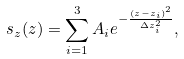Convert formula to latex. <formula><loc_0><loc_0><loc_500><loc_500>s _ { z } ( z ) = \sum _ { i = 1 } ^ { 3 } A _ { i } e ^ { - \frac { ( z - z _ { i } ) ^ { 2 } } { \Delta z _ { i } ^ { 2 } } } ,</formula> 